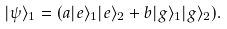Convert formula to latex. <formula><loc_0><loc_0><loc_500><loc_500>| \psi \rangle _ { 1 } = ( a | e \rangle _ { 1 } | e \rangle _ { 2 } + b | g \rangle _ { 1 } | g \rangle _ { 2 } ) .</formula> 